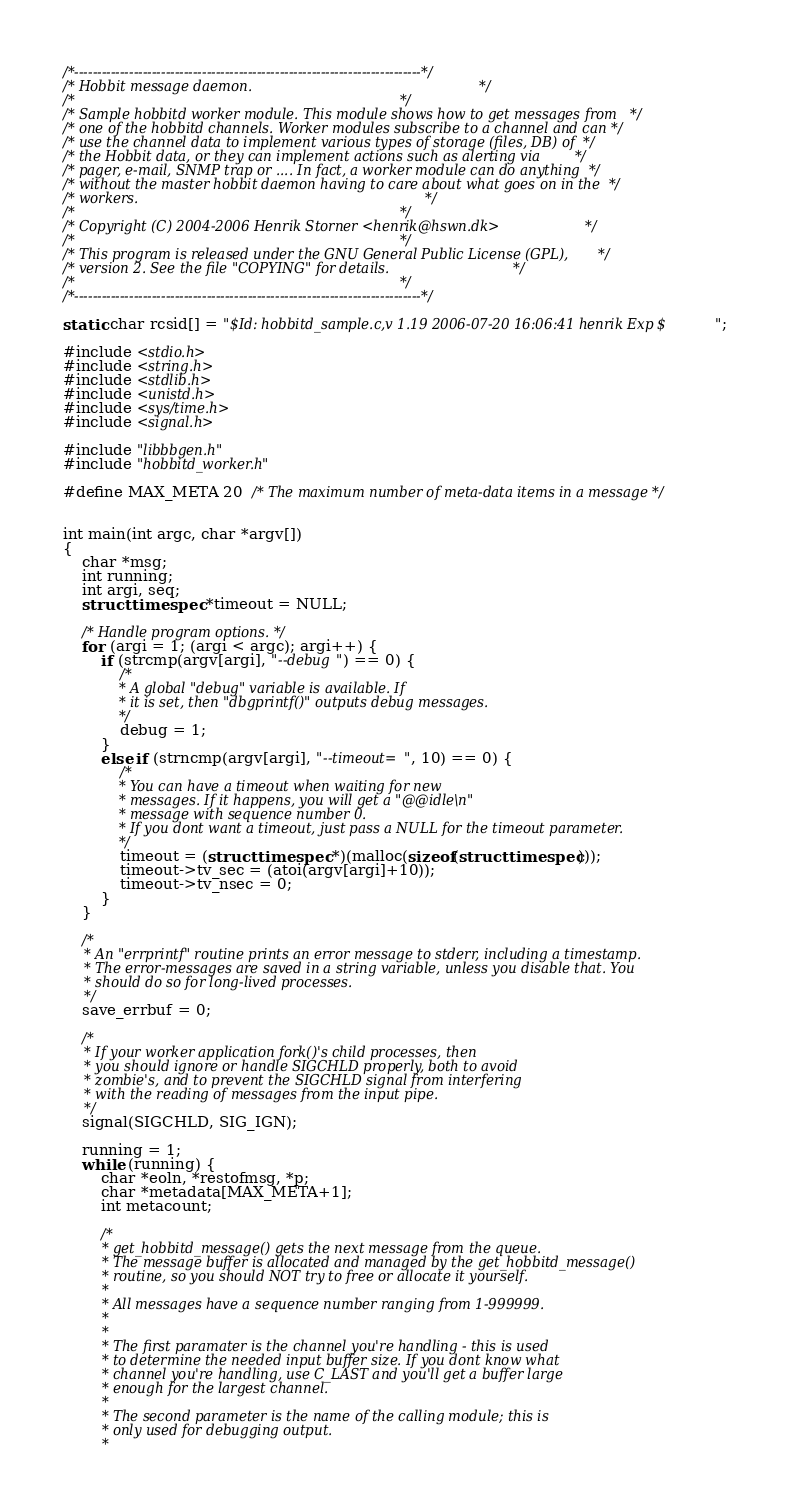<code> <loc_0><loc_0><loc_500><loc_500><_C_>/*----------------------------------------------------------------------------*/
/* Hobbit message daemon.                                                     */
/*                                                                            */
/* Sample hobbitd worker module. This module shows how to get messages from   */
/* one of the hobbitd channels. Worker modules subscribe to a channel and can */
/* use the channel data to implement various types of storage (files, DB) of  */
/* the Hobbit data, or they can implement actions such as alerting via        */
/* pager, e-mail, SNMP trap or .... In fact, a worker module can do anything  */
/* without the master hobbit daemon having to care about what goes on in the  */
/* workers.                                                                   */
/*                                                                            */
/* Copyright (C) 2004-2006 Henrik Storner <henrik@hswn.dk>                    */
/*                                                                            */
/* This program is released under the GNU General Public License (GPL),       */
/* version 2. See the file "COPYING" for details.                             */
/*                                                                            */
/*----------------------------------------------------------------------------*/

static char rcsid[] = "$Id: hobbitd_sample.c,v 1.19 2006-07-20 16:06:41 henrik Exp $";

#include <stdio.h>
#include <string.h>
#include <stdlib.h>
#include <unistd.h>
#include <sys/time.h>
#include <signal.h>

#include "libbbgen.h"
#include "hobbitd_worker.h"

#define MAX_META 20	/* The maximum number of meta-data items in a message */


int main(int argc, char *argv[])
{
	char *msg;
	int running;
	int argi, seq;
	struct timespec *timeout = NULL;

	/* Handle program options. */
	for (argi = 1; (argi < argc); argi++) {
		if (strcmp(argv[argi], "--debug") == 0) {
			/*
			 * A global "debug" variable is available. If
			 * it is set, then "dbgprintf()" outputs debug messages.
			 */
			debug = 1;
		}
		else if (strncmp(argv[argi], "--timeout=", 10) == 0) {
			/*
			 * You can have a timeout when waiting for new
			 * messages. If it happens, you will get a "@@idle\n"
			 * message with sequence number 0.
			 * If you dont want a timeout, just pass a NULL for the timeout parameter.
			 */
			timeout = (struct timespec *)(malloc(sizeof(struct timespec)));
			timeout->tv_sec = (atoi(argv[argi]+10));
			timeout->tv_nsec = 0;
		}
	}

	/*
	 * An "errprintf" routine prints an error message to stderr, including a timestamp.
	 * The error-messages are saved in a string variable, unless you disable that. You
	 * should do so for long-lived processes.
	 */
	save_errbuf = 0;

	/*
	 * If your worker application fork()'s child processes, then
	 * you should ignore or handle SIGCHLD properly, both to avoid
	 * zombie's, and to prevent the SIGCHLD signal from interfering
	 * with the reading of messages from the input pipe.
	 */
	signal(SIGCHLD, SIG_IGN);

	running = 1;
	while (running) {
		char *eoln, *restofmsg, *p;
		char *metadata[MAX_META+1];
		int metacount;

		/*
		 * get_hobbitd_message() gets the next message from the queue.
		 * The message buffer is allocated and managed by the get_hobbitd_message()
		 * routine, so you should NOT try to free or allocate it yourself.
		 *
		 * All messages have a sequence number ranging from 1-999999.
		 *
		 *
		 * The first paramater is the channel you're handling - this is used
		 * to determine the needed input buffer size. If you dont know what
		 * channel you're handling, use C_LAST and you'll get a buffer large
		 * enough for the largest channel.
		 *
		 * The second parameter is the name of the calling module; this is
		 * only used for debugging output.
		 *</code> 